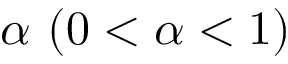<formula> <loc_0><loc_0><loc_500><loc_500>\alpha \ ( 0 < \alpha < 1 )</formula> 